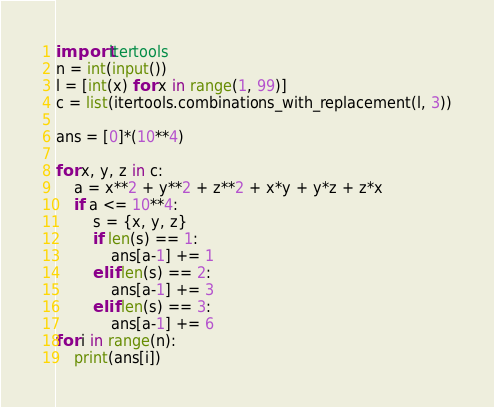Convert code to text. <code><loc_0><loc_0><loc_500><loc_500><_Python_>import itertools
n = int(input())
l = [int(x) for x in range(1, 99)]
c = list(itertools.combinations_with_replacement(l, 3))

ans = [0]*(10**4)

for x, y, z in c:
    a = x**2 + y**2 + z**2 + x*y + y*z + z*x
    if a <= 10**4:
        s = {x, y, z}
        if len(s) == 1:
            ans[a-1] += 1
        elif len(s) == 2:
            ans[a-1] += 3
        elif len(s) == 3:
            ans[a-1] += 6
for i in range(n):
    print(ans[i])</code> 